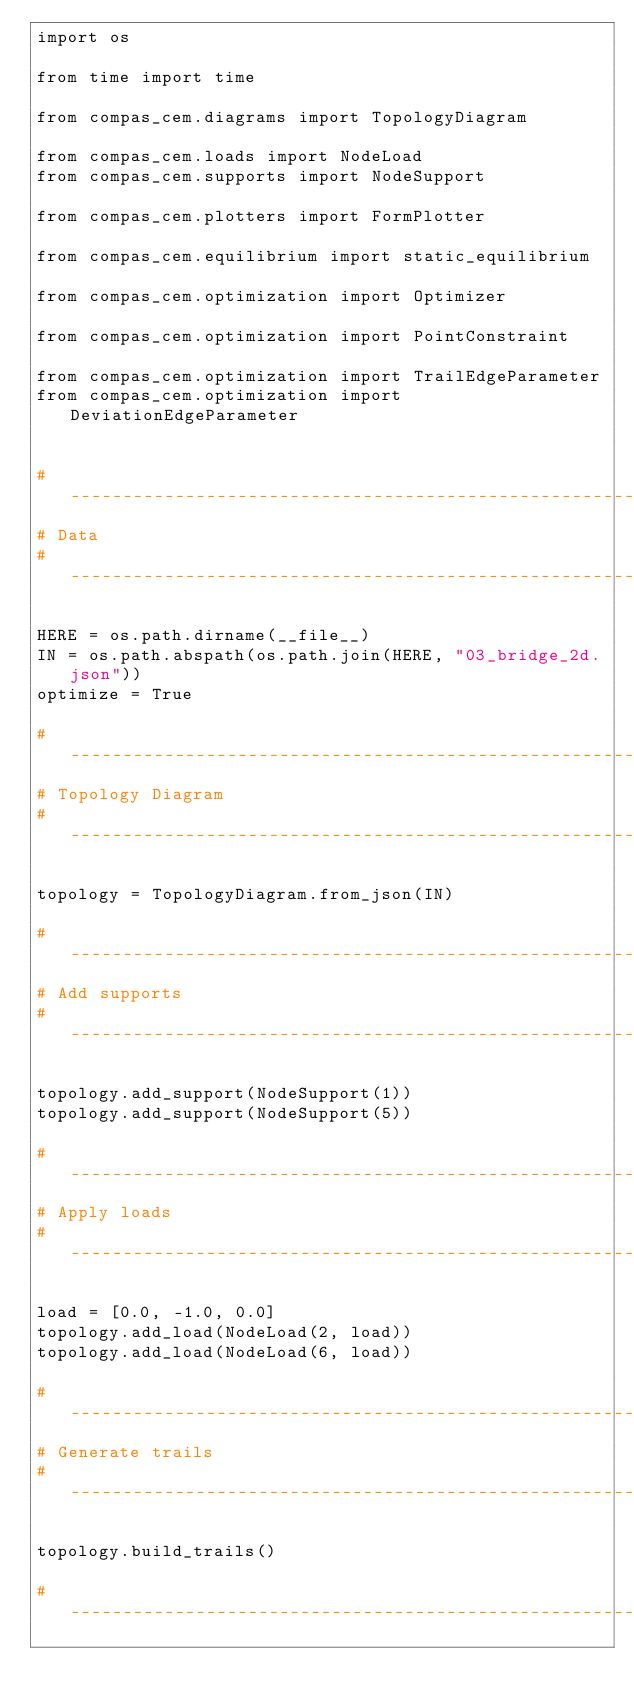<code> <loc_0><loc_0><loc_500><loc_500><_Python_>import os

from time import time

from compas_cem.diagrams import TopologyDiagram

from compas_cem.loads import NodeLoad
from compas_cem.supports import NodeSupport

from compas_cem.plotters import FormPlotter

from compas_cem.equilibrium import static_equilibrium

from compas_cem.optimization import Optimizer

from compas_cem.optimization import PointConstraint

from compas_cem.optimization import TrailEdgeParameter
from compas_cem.optimization import DeviationEdgeParameter


# ------------------------------------------------------------------------------
# Data
#-------------------------------------------------------------------------------

HERE = os.path.dirname(__file__)
IN = os.path.abspath(os.path.join(HERE, "03_bridge_2d.json"))
optimize = True

# ------------------------------------------------------------------------------
# Topology Diagram
# ------------------------------------------------------------------------------

topology = TopologyDiagram.from_json(IN)

# ------------------------------------------------------------------------------
# Add supports
# ------------------------------------------------------------------------------

topology.add_support(NodeSupport(1))
topology.add_support(NodeSupport(5))

# ------------------------------------------------------------------------------
# Apply loads
# ------------------------------------------------------------------------------

load = [0.0, -1.0, 0.0]
topology.add_load(NodeLoad(2, load))
topology.add_load(NodeLoad(6, load))

# ------------------------------------------------------------------------------
# Generate trails
# ------------------------------------------------------------------------------

topology.build_trails()

# ------------------------------------------------------------------------------</code> 